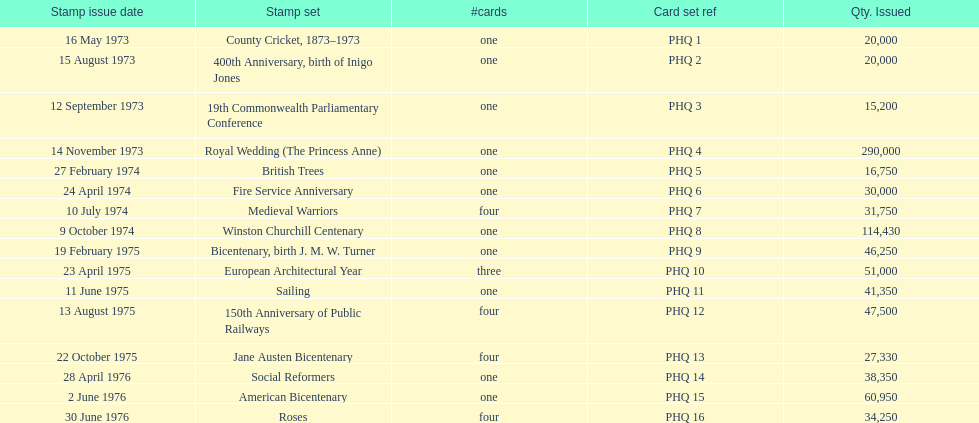List each bicentenary stamp set Bicentenary, birth J. M. W. Turner, Jane Austen Bicentenary, American Bicentenary. 